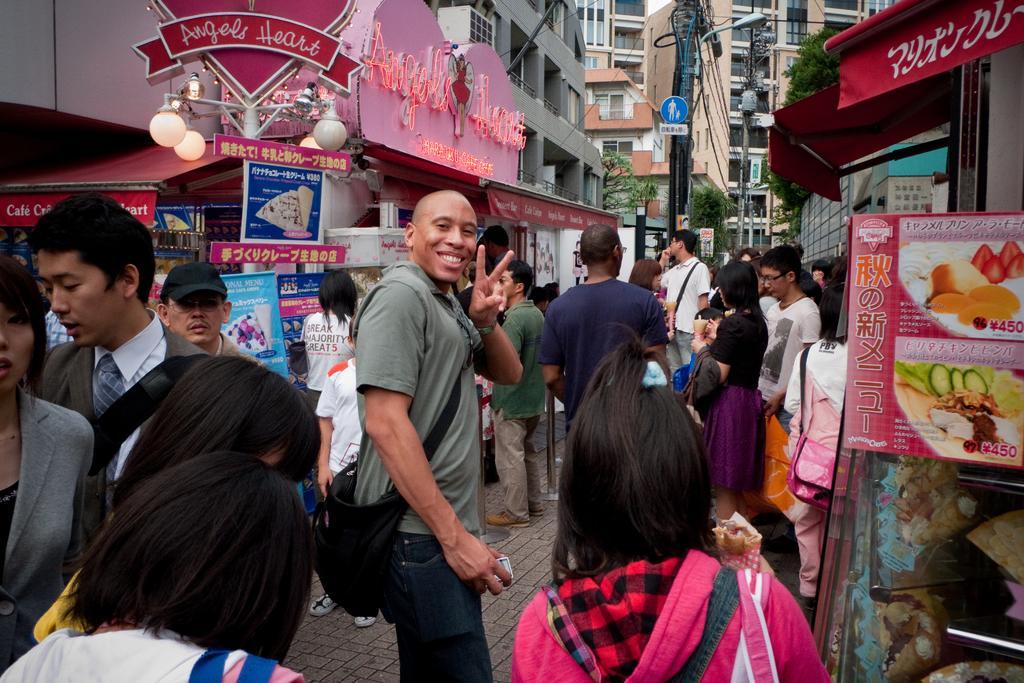Describe this image in one or two sentences. In this image I see number of people in which this man is smiling and I see that he is carrying a bag and I see number of stalls and I see boards on which there are words and pictures on it. In the background I see the buildings and I see the pole and I see the wires over here and I see the trees. 